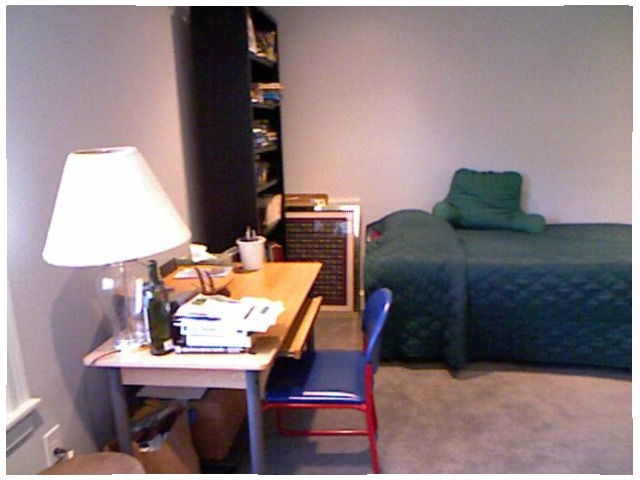<image>
Can you confirm if the pillow is in front of the comforter? No. The pillow is not in front of the comforter. The spatial positioning shows a different relationship between these objects. Is there a books on the cupboard? Yes. Looking at the image, I can see the books is positioned on top of the cupboard, with the cupboard providing support. Is the lamp on the table? Yes. Looking at the image, I can see the lamp is positioned on top of the table, with the table providing support. Is the chair on the table? No. The chair is not positioned on the table. They may be near each other, but the chair is not supported by or resting on top of the table. Is the painting on the bed? No. The painting is not positioned on the bed. They may be near each other, but the painting is not supported by or resting on top of the bed. Is the chair to the right of the desk? No. The chair is not to the right of the desk. The horizontal positioning shows a different relationship. Is the box under the bottle? Yes. The box is positioned underneath the bottle, with the bottle above it in the vertical space. 